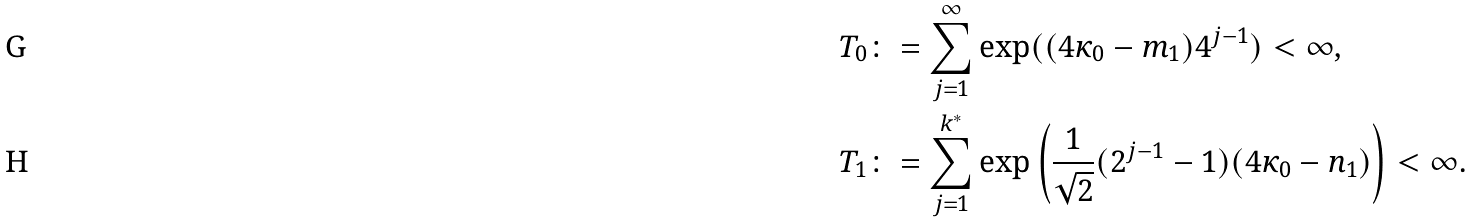Convert formula to latex. <formula><loc_0><loc_0><loc_500><loc_500>T _ { 0 } & \colon = \sum ^ { \infty } _ { j = 1 } \exp ( ( 4 \kappa _ { 0 } - m _ { 1 } ) 4 ^ { j - 1 } ) < \infty , \\ T _ { 1 } & \colon = \sum ^ { k ^ { * } } _ { j = 1 } \exp \left ( \frac { 1 } { \sqrt { 2 } } ( 2 ^ { j - 1 } - 1 ) ( 4 \kappa _ { 0 } - n _ { 1 } ) \right ) < \infty .</formula> 